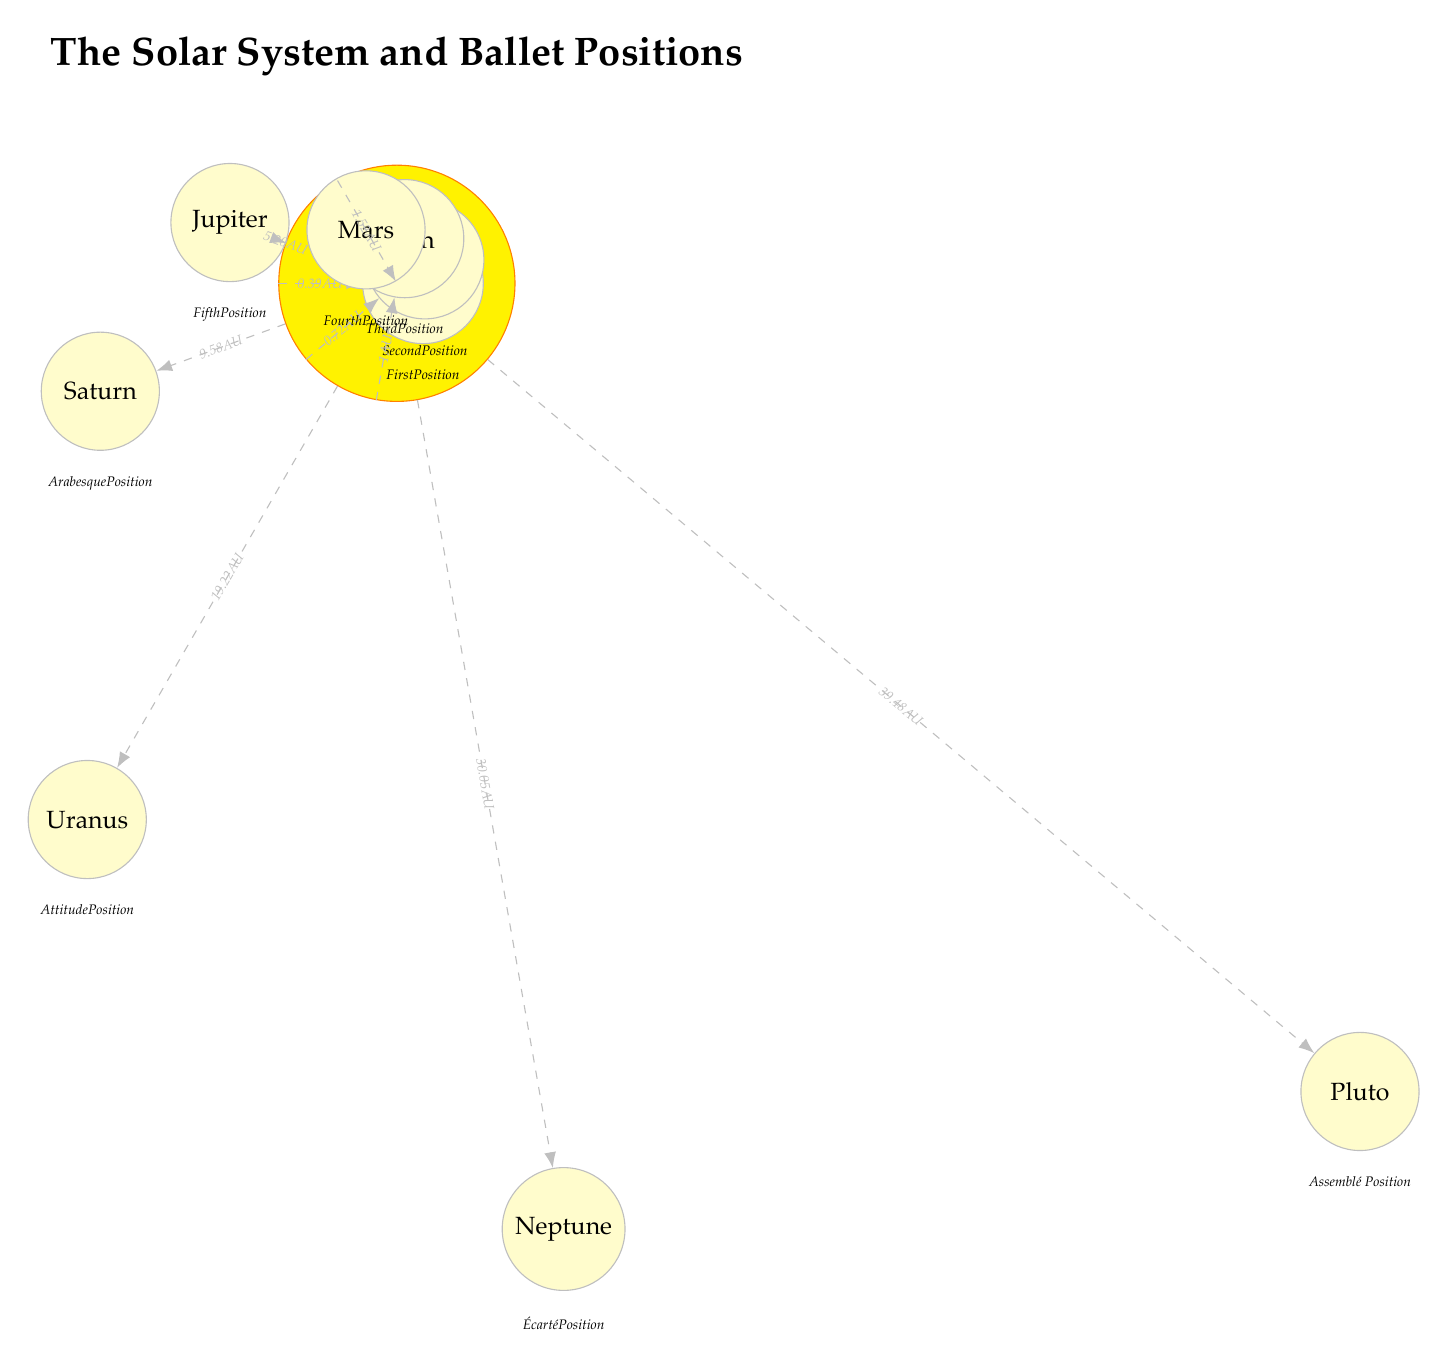What is the distance of Mars from the Sun? The diagram shows that Mars has a distance of 1.52 AU from the Sun, which is indicated next to the label for Mars.
Answer: 1.52 AU How many planets are represented in the diagram? The diagram lists a total of 9 planets, including Pluto, as each planet is represented by a node connected to the Sun.
Answer: 9 What ballet position corresponds with Saturn? The diagram specifies that Saturn corresponds to the ballet position "Arabesque," as indicated directly below the Saturn node.
Answer: Arabesque Which planet is farthest from the Sun? The diagram lists Pluto at a distance of 39.48 AU from the Sun, making it the farthest planet shown in the diagram.
Answer: Pluto What is the ballet position for the second planet from the Sun? The second planet from the Sun is Venus, which corresponds to the ballet position "Second," as shown below the Venus node in the diagram.
Answer: Second Which planet is at a distance of 30.05 AU? The diagram indicates that the planet at this distance from the Sun is Neptune, as shown next to its label in the diagram.
Answer: Neptune How is the position "Fourth" described in the diagram? The position "Fourth" corresponds to the planet Mars, which is indicated directly below the Mars node, showing its connection to the stated ballet position.
Answer: Mars What is the angular position of Jupiter? The diagram indicates that Jupiter is at an angular position of 160 degrees, which is specified next to the labels for each planet.
Answer: 160 degrees Which planet corresponds to the ballet position "Écarté"? The diagram shows that Uranus corresponds to the ballet position "Écarté," as specified below the Uranus node.
Answer: Écarté 